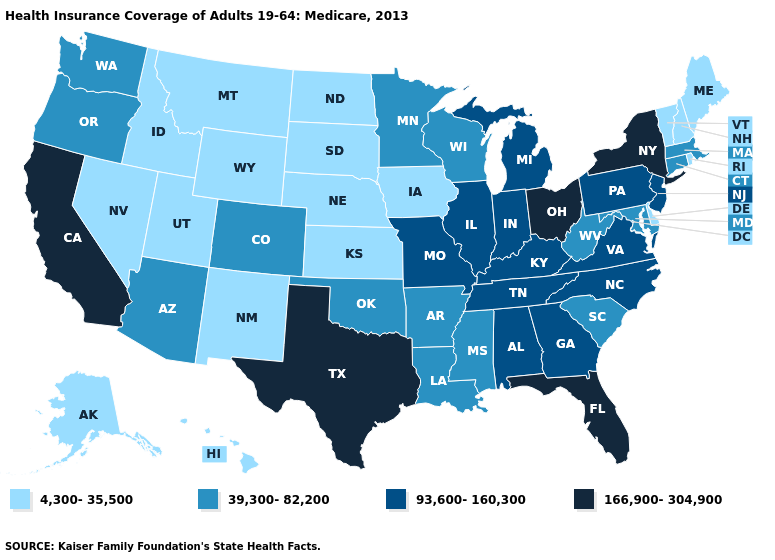What is the value of Pennsylvania?
Quick response, please. 93,600-160,300. Among the states that border Nevada , which have the lowest value?
Concise answer only. Idaho, Utah. What is the lowest value in the USA?
Concise answer only. 4,300-35,500. Which states hav the highest value in the Northeast?
Keep it brief. New York. What is the value of New Mexico?
Write a very short answer. 4,300-35,500. Name the states that have a value in the range 39,300-82,200?
Quick response, please. Arizona, Arkansas, Colorado, Connecticut, Louisiana, Maryland, Massachusetts, Minnesota, Mississippi, Oklahoma, Oregon, South Carolina, Washington, West Virginia, Wisconsin. Does Maine have a higher value than Wyoming?
Keep it brief. No. What is the value of Arkansas?
Quick response, please. 39,300-82,200. Name the states that have a value in the range 93,600-160,300?
Be succinct. Alabama, Georgia, Illinois, Indiana, Kentucky, Michigan, Missouri, New Jersey, North Carolina, Pennsylvania, Tennessee, Virginia. Which states have the lowest value in the Northeast?
Answer briefly. Maine, New Hampshire, Rhode Island, Vermont. Name the states that have a value in the range 93,600-160,300?
Give a very brief answer. Alabama, Georgia, Illinois, Indiana, Kentucky, Michigan, Missouri, New Jersey, North Carolina, Pennsylvania, Tennessee, Virginia. What is the value of Missouri?
Keep it brief. 93,600-160,300. Name the states that have a value in the range 166,900-304,900?
Answer briefly. California, Florida, New York, Ohio, Texas. Name the states that have a value in the range 39,300-82,200?
Give a very brief answer. Arizona, Arkansas, Colorado, Connecticut, Louisiana, Maryland, Massachusetts, Minnesota, Mississippi, Oklahoma, Oregon, South Carolina, Washington, West Virginia, Wisconsin. Name the states that have a value in the range 93,600-160,300?
Give a very brief answer. Alabama, Georgia, Illinois, Indiana, Kentucky, Michigan, Missouri, New Jersey, North Carolina, Pennsylvania, Tennessee, Virginia. 